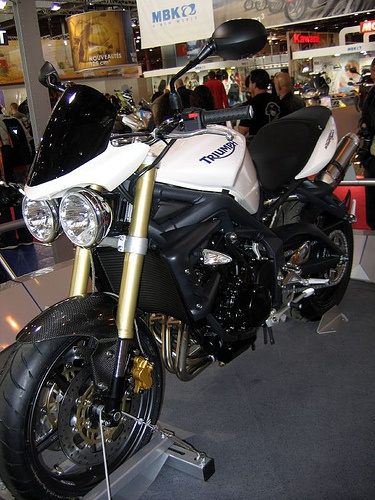Describe the objects in this image and their specific colors. I can see motorcycle in lavender, black, white, gray, and darkgray tones, people in lavender, black, maroon, and gray tones, people in lavender, black, maroon, and gray tones, people in lavender, black, gray, and maroon tones, and people in lavender, black, maroon, and gray tones in this image. 